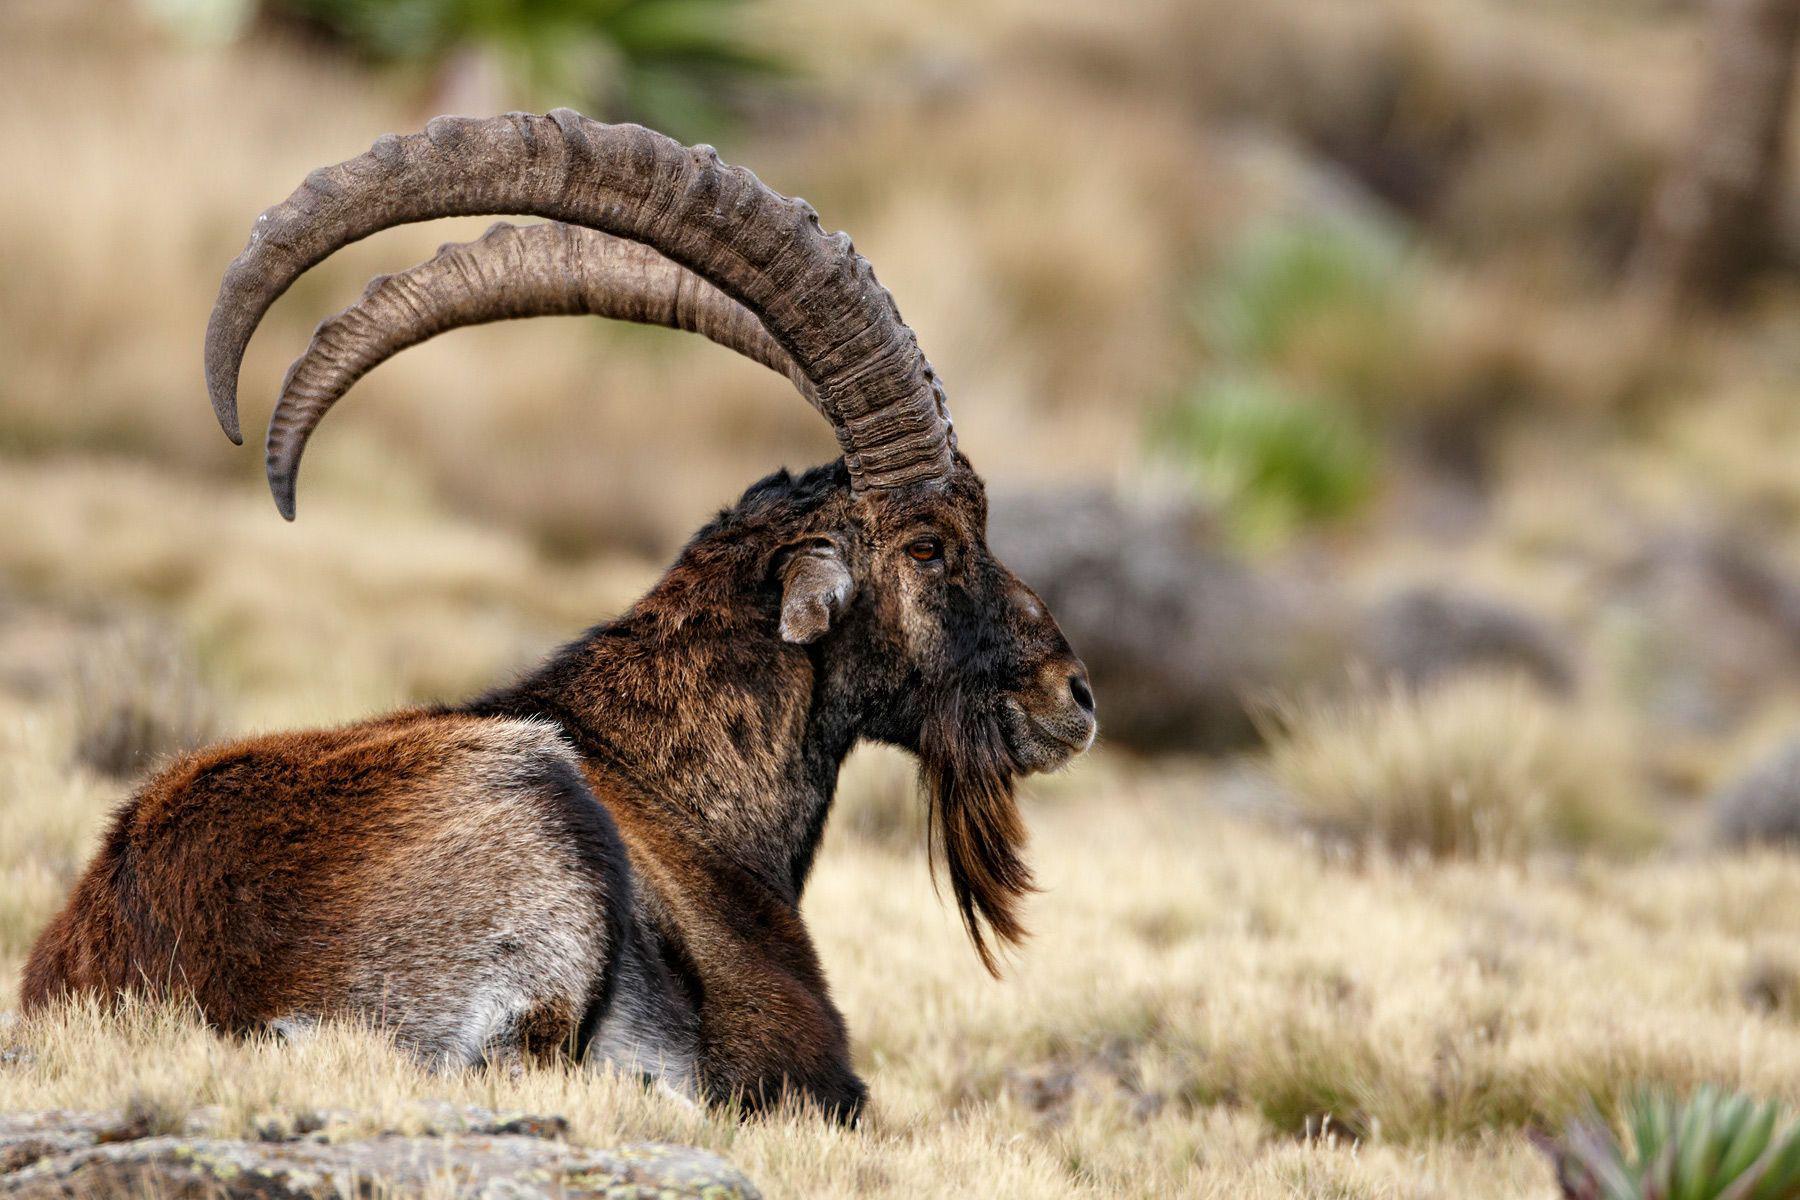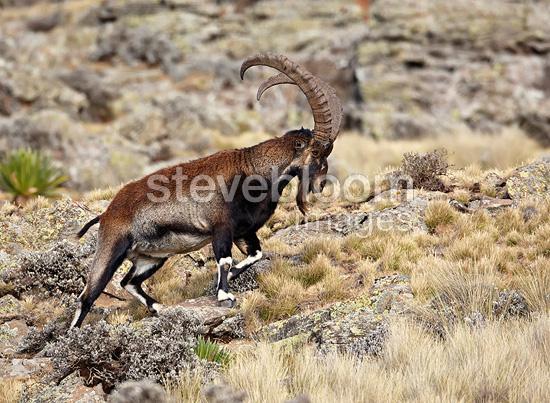The first image is the image on the left, the second image is the image on the right. Examine the images to the left and right. Is the description "Each image depicts one horned animal, and the horned animals in the left and right images face the same direction." accurate? Answer yes or no. Yes. The first image is the image on the left, the second image is the image on the right. Examine the images to the left and right. Is the description "The left and right image contains the same number of goats standing in opposite directions." accurate? Answer yes or no. No. 